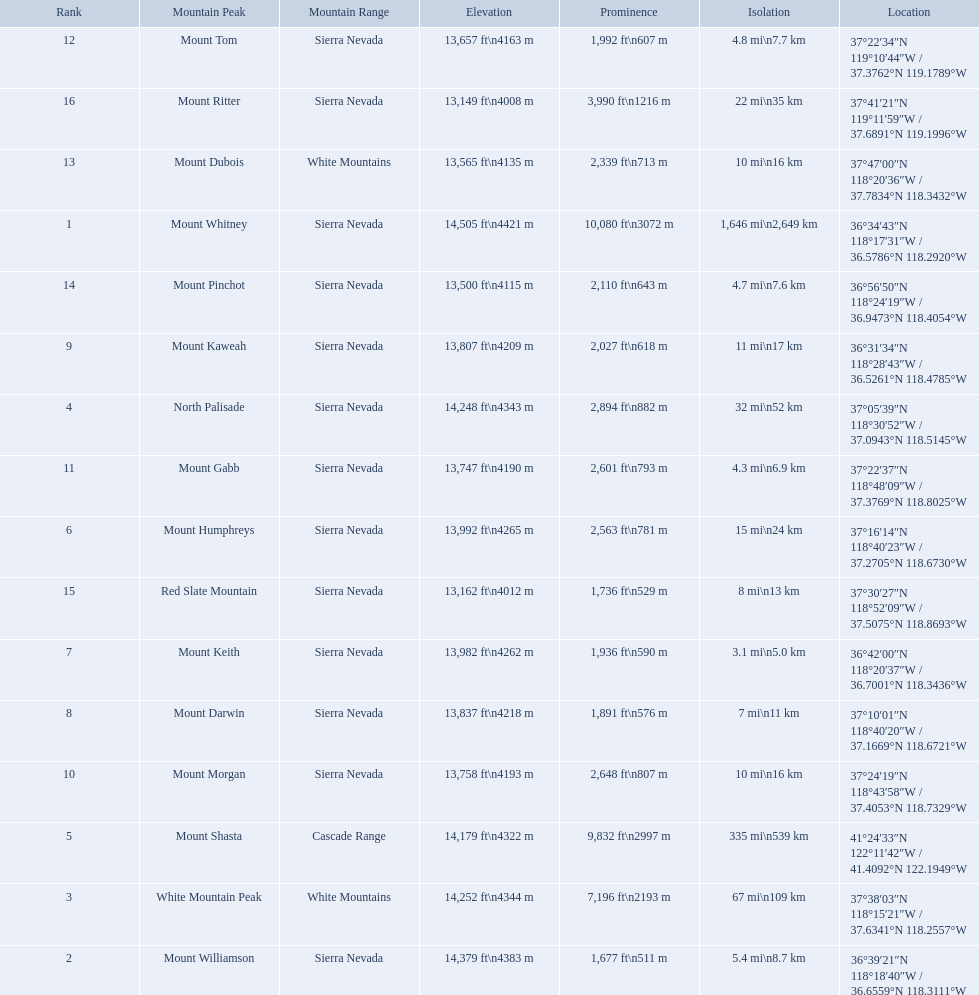Which are the mountain peaks? Mount Whitney, Mount Williamson, White Mountain Peak, North Palisade, Mount Shasta, Mount Humphreys, Mount Keith, Mount Darwin, Mount Kaweah, Mount Morgan, Mount Gabb, Mount Tom, Mount Dubois, Mount Pinchot, Red Slate Mountain, Mount Ritter. Of these, which is in the cascade range? Mount Shasta. Which mountain peaks have a prominence over 9,000 ft? Mount Whitney, Mount Shasta. Of those, which one has the the highest prominence? Mount Whitney. 